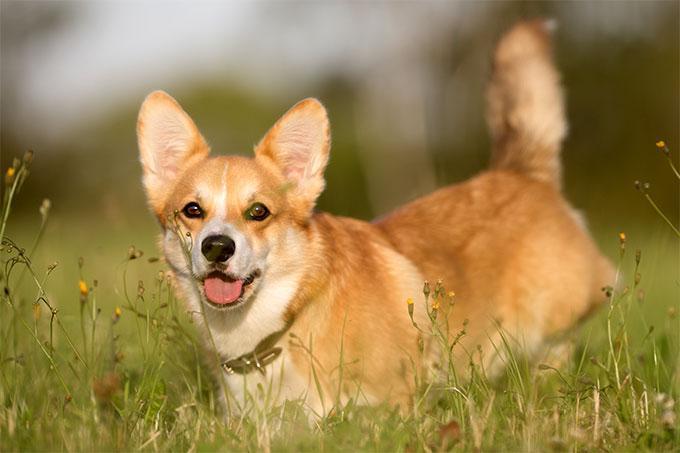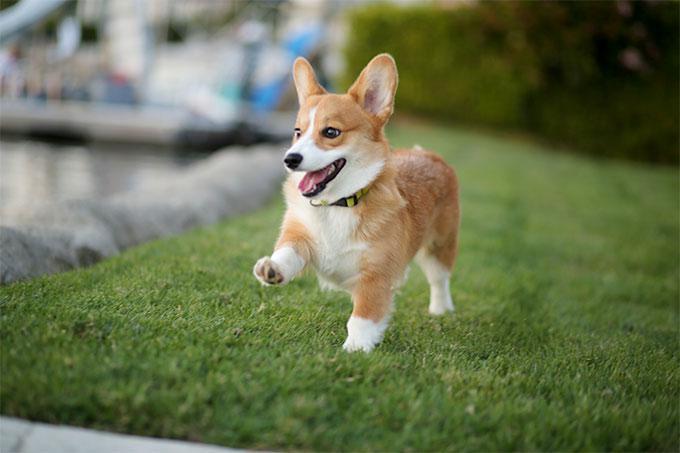The first image is the image on the left, the second image is the image on the right. Analyze the images presented: Is the assertion "There is a tri-colored dog with a black mask look." valid? Answer yes or no. No. The first image is the image on the left, the second image is the image on the right. Evaluate the accuracy of this statement regarding the images: "Two tan and white dogs have short legs and upright ears.". Is it true? Answer yes or no. Yes. The first image is the image on the left, the second image is the image on the right. Analyze the images presented: Is the assertion "An image shows a corgi dog bounding across the grass, with at least one front paw raised." valid? Answer yes or no. Yes. The first image is the image on the left, the second image is the image on the right. Evaluate the accuracy of this statement regarding the images: "Two corgies have their ears pointed upward and their mouths open and smiling with tongues showing.". Is it true? Answer yes or no. Yes. 